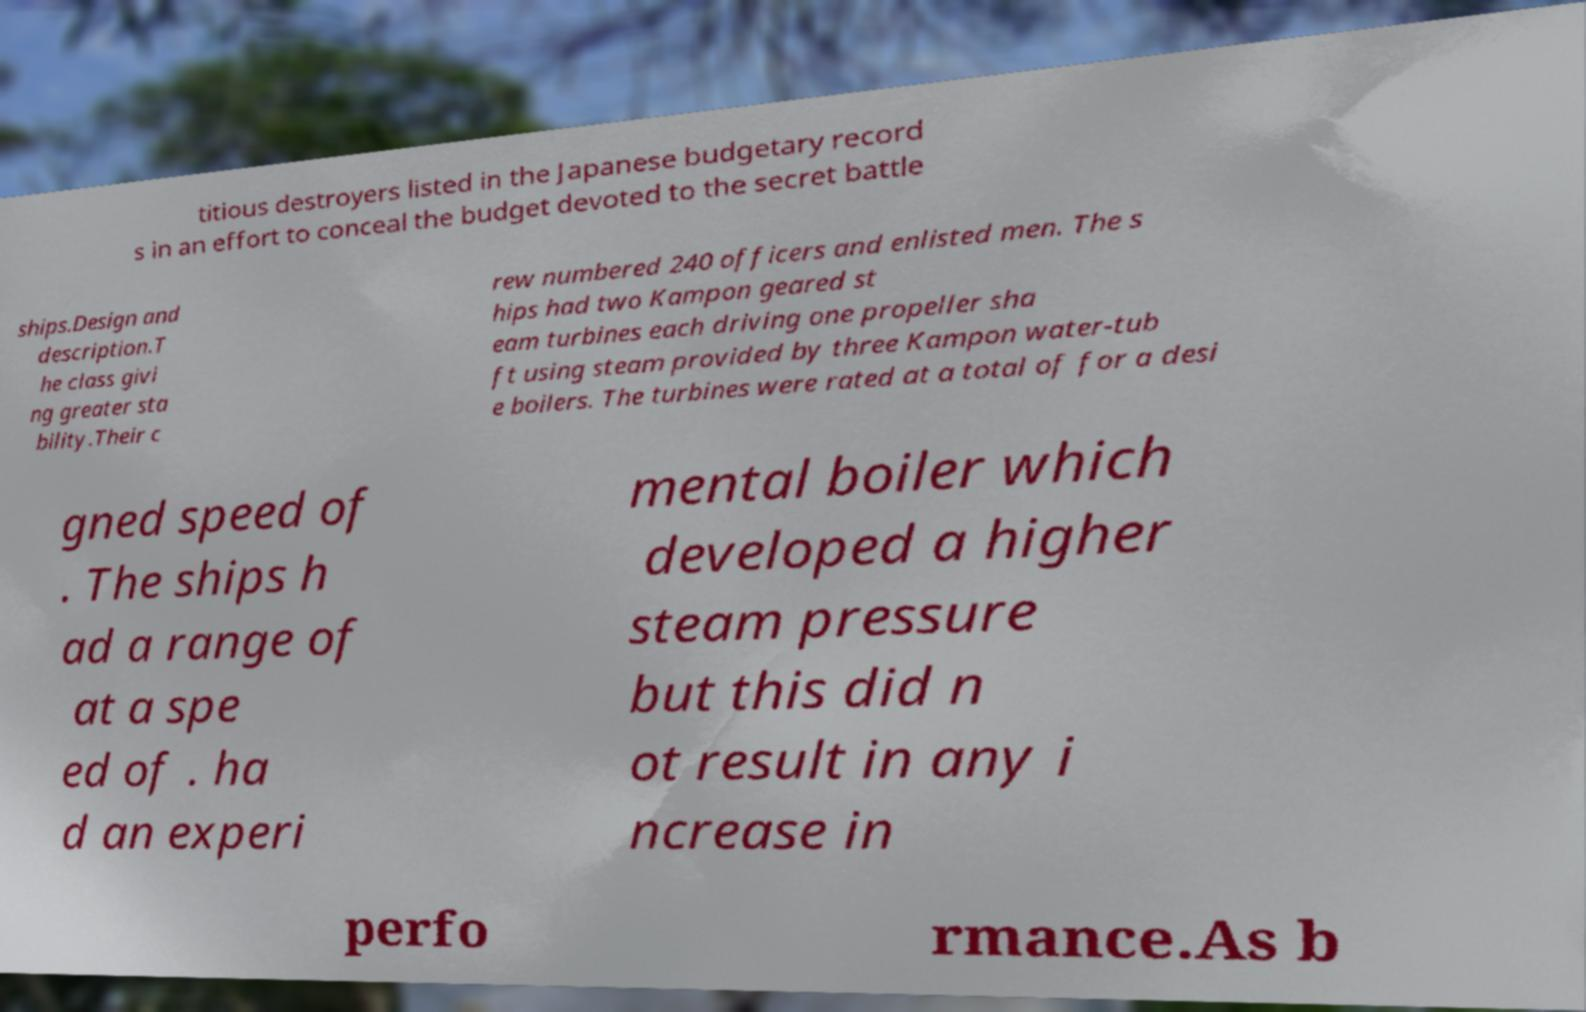Can you accurately transcribe the text from the provided image for me? titious destroyers listed in the Japanese budgetary record s in an effort to conceal the budget devoted to the secret battle ships.Design and description.T he class givi ng greater sta bility.Their c rew numbered 240 officers and enlisted men. The s hips had two Kampon geared st eam turbines each driving one propeller sha ft using steam provided by three Kampon water-tub e boilers. The turbines were rated at a total of for a desi gned speed of . The ships h ad a range of at a spe ed of . ha d an experi mental boiler which developed a higher steam pressure but this did n ot result in any i ncrease in perfo rmance.As b 